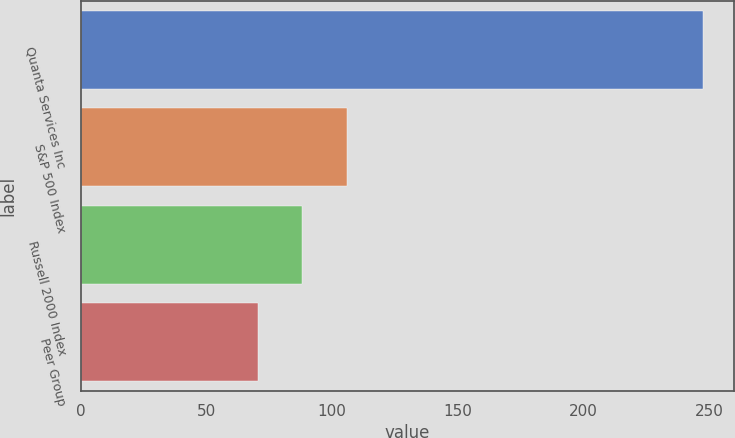Convert chart to OTSL. <chart><loc_0><loc_0><loc_500><loc_500><bar_chart><fcel>Quanta Services Inc<fcel>S&P 500 Index<fcel>Russell 2000 Index<fcel>Peer Group<nl><fcel>247.5<fcel>105.73<fcel>88.01<fcel>70.29<nl></chart> 